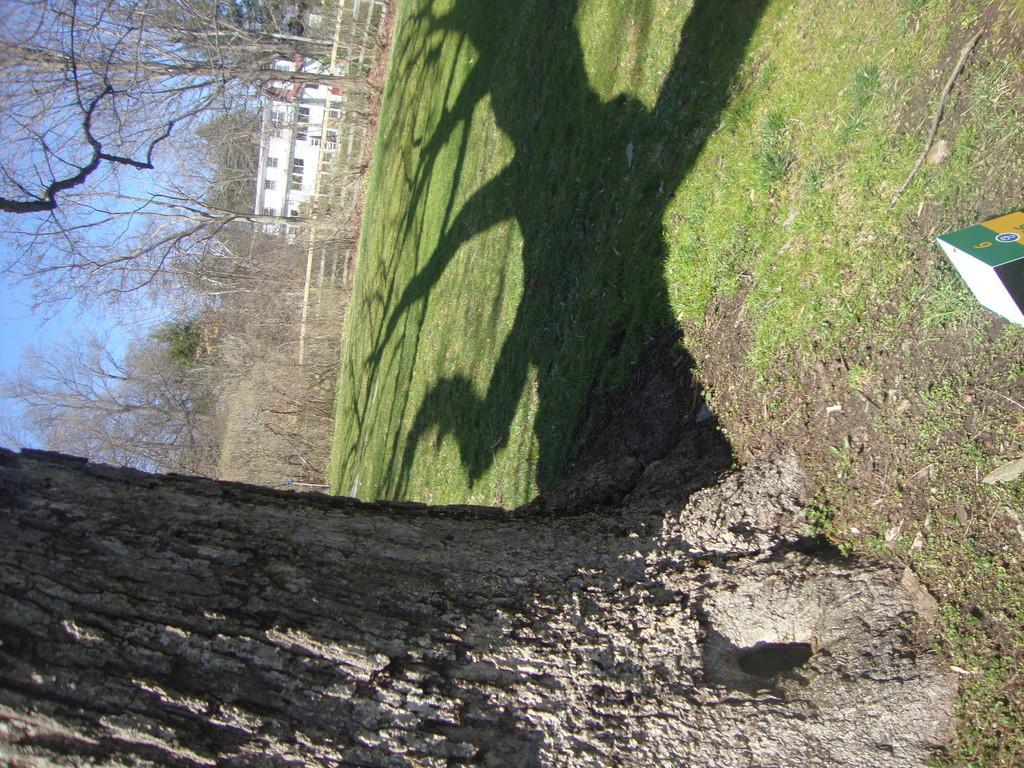In one or two sentences, can you explain what this image depicts? This image is taken outdoors. At the bottom of the image there is a ground with grass on it and there is a tree. On the left side of the image there are many trees and plants. There is a house and there is a sky. 